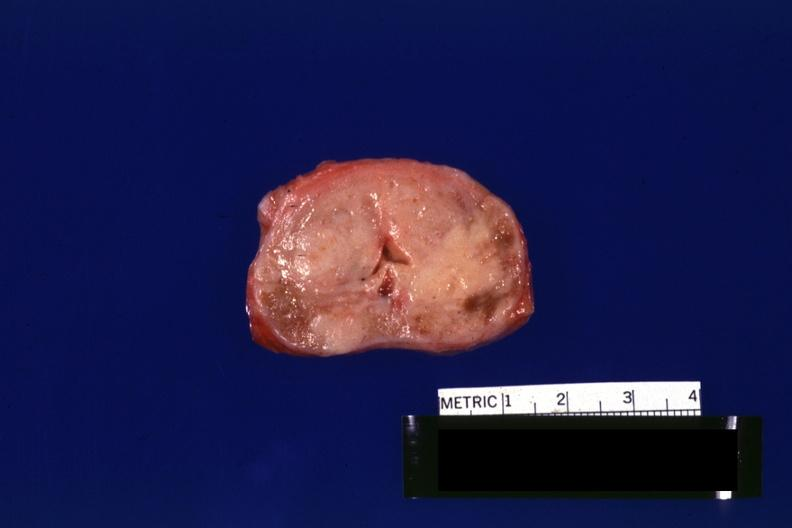s neoplasm gland not enlarged?
Answer the question using a single word or phrase. Yes 